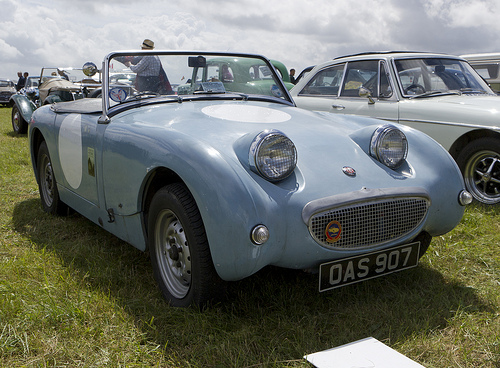<image>
Is the car to the left of the car? Yes. From this viewpoint, the car is positioned to the left side relative to the car. Is there a man behind the car? Yes. From this viewpoint, the man is positioned behind the car, with the car partially or fully occluding the man. Is there a man in the car? No. The man is not contained within the car. These objects have a different spatial relationship. 